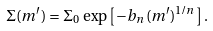<formula> <loc_0><loc_0><loc_500><loc_500>\Sigma ( m ^ { \prime } ) = \Sigma _ { 0 } \, \exp \left [ - b _ { n } \, ( m ^ { \prime } ) ^ { 1 / n } \right ] .</formula> 